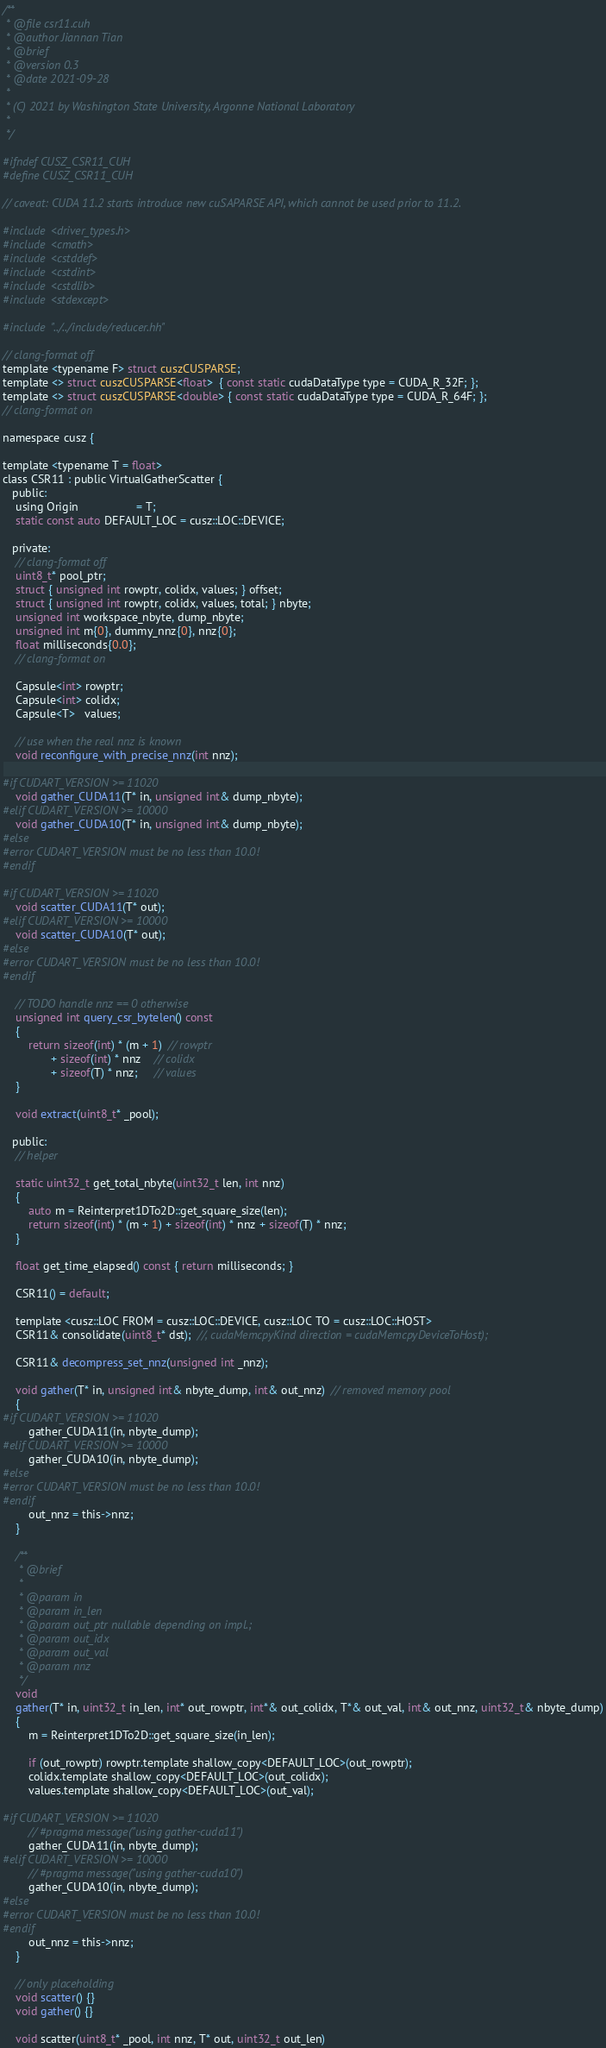<code> <loc_0><loc_0><loc_500><loc_500><_Cuda_>/**
 * @file csr11.cuh
 * @author Jiannan Tian
 * @brief
 * @version 0.3
 * @date 2021-09-28
 *
 * (C) 2021 by Washington State University, Argonne National Laboratory
 *
 */

#ifndef CUSZ_CSR11_CUH
#define CUSZ_CSR11_CUH

// caveat: CUDA 11.2 starts introduce new cuSAPARSE API, which cannot be used prior to 11.2.

#include <driver_types.h>
#include <cmath>
#include <cstddef>
#include <cstdint>
#include <cstdlib>
#include <stdexcept>

#include "../../include/reducer.hh"

// clang-format off
template <typename F> struct cuszCUSPARSE;
template <> struct cuszCUSPARSE<float>  { const static cudaDataType type = CUDA_R_32F; };
template <> struct cuszCUSPARSE<double> { const static cudaDataType type = CUDA_R_64F; };
// clang-format on

namespace cusz {

template <typename T = float>
class CSR11 : public VirtualGatherScatter {
   public:
    using Origin                  = T;
    static const auto DEFAULT_LOC = cusz::LOC::DEVICE;

   private:
    // clang-format off
    uint8_t* pool_ptr;
    struct { unsigned int rowptr, colidx, values; } offset;
    struct { unsigned int rowptr, colidx, values, total; } nbyte;
    unsigned int workspace_nbyte, dump_nbyte;
    unsigned int m{0}, dummy_nnz{0}, nnz{0};
    float milliseconds{0.0};
    // clang-format on

    Capsule<int> rowptr;
    Capsule<int> colidx;
    Capsule<T>   values;

    // use when the real nnz is known
    void reconfigure_with_precise_nnz(int nnz);

#if CUDART_VERSION >= 11020
    void gather_CUDA11(T* in, unsigned int& dump_nbyte);
#elif CUDART_VERSION >= 10000
    void gather_CUDA10(T* in, unsigned int& dump_nbyte);
#else
#error CUDART_VERSION must be no less than 10.0!
#endif

#if CUDART_VERSION >= 11020
    void scatter_CUDA11(T* out);
#elif CUDART_VERSION >= 10000
    void scatter_CUDA10(T* out);
#else
#error CUDART_VERSION must be no less than 10.0!
#endif

    // TODO handle nnz == 0 otherwise
    unsigned int query_csr_bytelen() const
    {
        return sizeof(int) * (m + 1)  // rowptr
               + sizeof(int) * nnz    // colidx
               + sizeof(T) * nnz;     // values
    }

    void extract(uint8_t* _pool);

   public:
    // helper

    static uint32_t get_total_nbyte(uint32_t len, int nnz)
    {
        auto m = Reinterpret1DTo2D::get_square_size(len);
        return sizeof(int) * (m + 1) + sizeof(int) * nnz + sizeof(T) * nnz;
    }

    float get_time_elapsed() const { return milliseconds; }

    CSR11() = default;

    template <cusz::LOC FROM = cusz::LOC::DEVICE, cusz::LOC TO = cusz::LOC::HOST>
    CSR11& consolidate(uint8_t* dst);  //, cudaMemcpyKind direction = cudaMemcpyDeviceToHost);

    CSR11& decompress_set_nnz(unsigned int _nnz);

    void gather(T* in, unsigned int& nbyte_dump, int& out_nnz)  // removed memory pool
    {
#if CUDART_VERSION >= 11020
        gather_CUDA11(in, nbyte_dump);
#elif CUDART_VERSION >= 10000
        gather_CUDA10(in, nbyte_dump);
#else
#error CUDART_VERSION must be no less than 10.0!
#endif
        out_nnz = this->nnz;
    }

    /**
     * @brief
     *
     * @param in
     * @param in_len
     * @param out_ptr nullable depending on impl.;
     * @param out_idx
     * @param out_val
     * @param nnz
     */
    void
    gather(T* in, uint32_t in_len, int* out_rowptr, int*& out_colidx, T*& out_val, int& out_nnz, uint32_t& nbyte_dump)
    {
        m = Reinterpret1DTo2D::get_square_size(in_len);

        if (out_rowptr) rowptr.template shallow_copy<DEFAULT_LOC>(out_rowptr);
        colidx.template shallow_copy<DEFAULT_LOC>(out_colidx);
        values.template shallow_copy<DEFAULT_LOC>(out_val);

#if CUDART_VERSION >= 11020
        // #pragma message("using gather-cuda11")
        gather_CUDA11(in, nbyte_dump);
#elif CUDART_VERSION >= 10000
        // #pragma message("using gather-cuda10")
        gather_CUDA10(in, nbyte_dump);
#else
#error CUDART_VERSION must be no less than 10.0!
#endif
        out_nnz = this->nnz;
    }

    // only placeholding
    void scatter() {}
    void gather() {}

    void scatter(uint8_t* _pool, int nnz, T* out, uint32_t out_len)</code> 